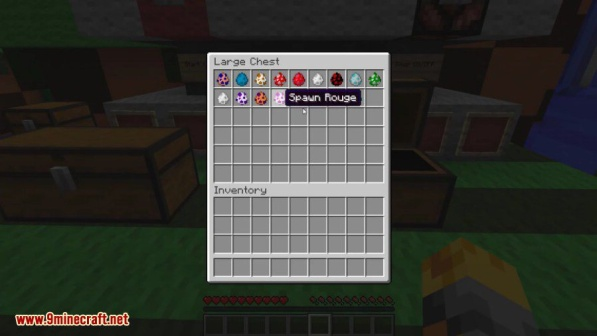What do you think is going on in this snapshot? In this snapshot from the game Minecraft, we see a player accessing the contents of a 'Large Chest' using their in-game inventory menu. The chest is filled with various colored spawn eggs, each capable of summoning a different creature into the Minecraft world. Items such as diamonds, enchanted books, flowers, potions, and other unique items are visible, hinting at extensive gameplay and adventure.

The surroundings show a serene, grassy area, featuring other chests and a crafting table, which indicates a well-established base. Despite the full chest, the player's personal inventory is empty, suggesting that they might be either organizing their items or about to set off on a new adventure. The labels 'Large Chest' and 'Inventory' provide clarity, ensuring players understand their in-game actions and resources.

Overall, the image captures a moment of organization and preparation, with the player engaging with their inventory in a tranquil setting, ready to take on the next challenge Minecraft offers. 